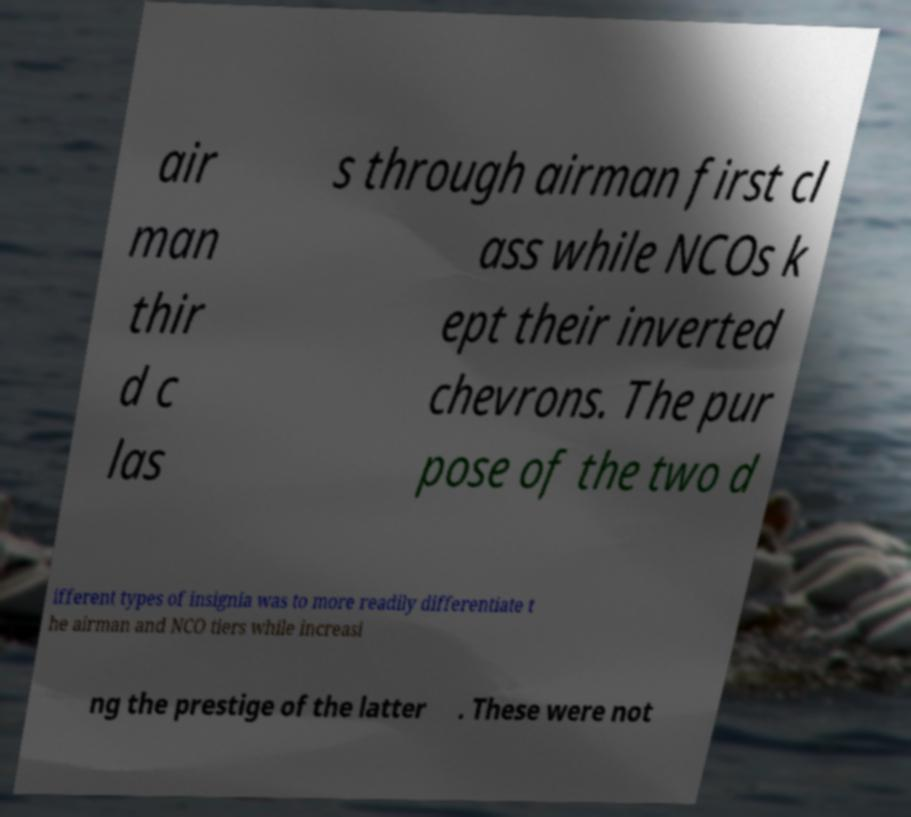Could you assist in decoding the text presented in this image and type it out clearly? air man thir d c las s through airman first cl ass while NCOs k ept their inverted chevrons. The pur pose of the two d ifferent types of insignia was to more readily differentiate t he airman and NCO tiers while increasi ng the prestige of the latter . These were not 